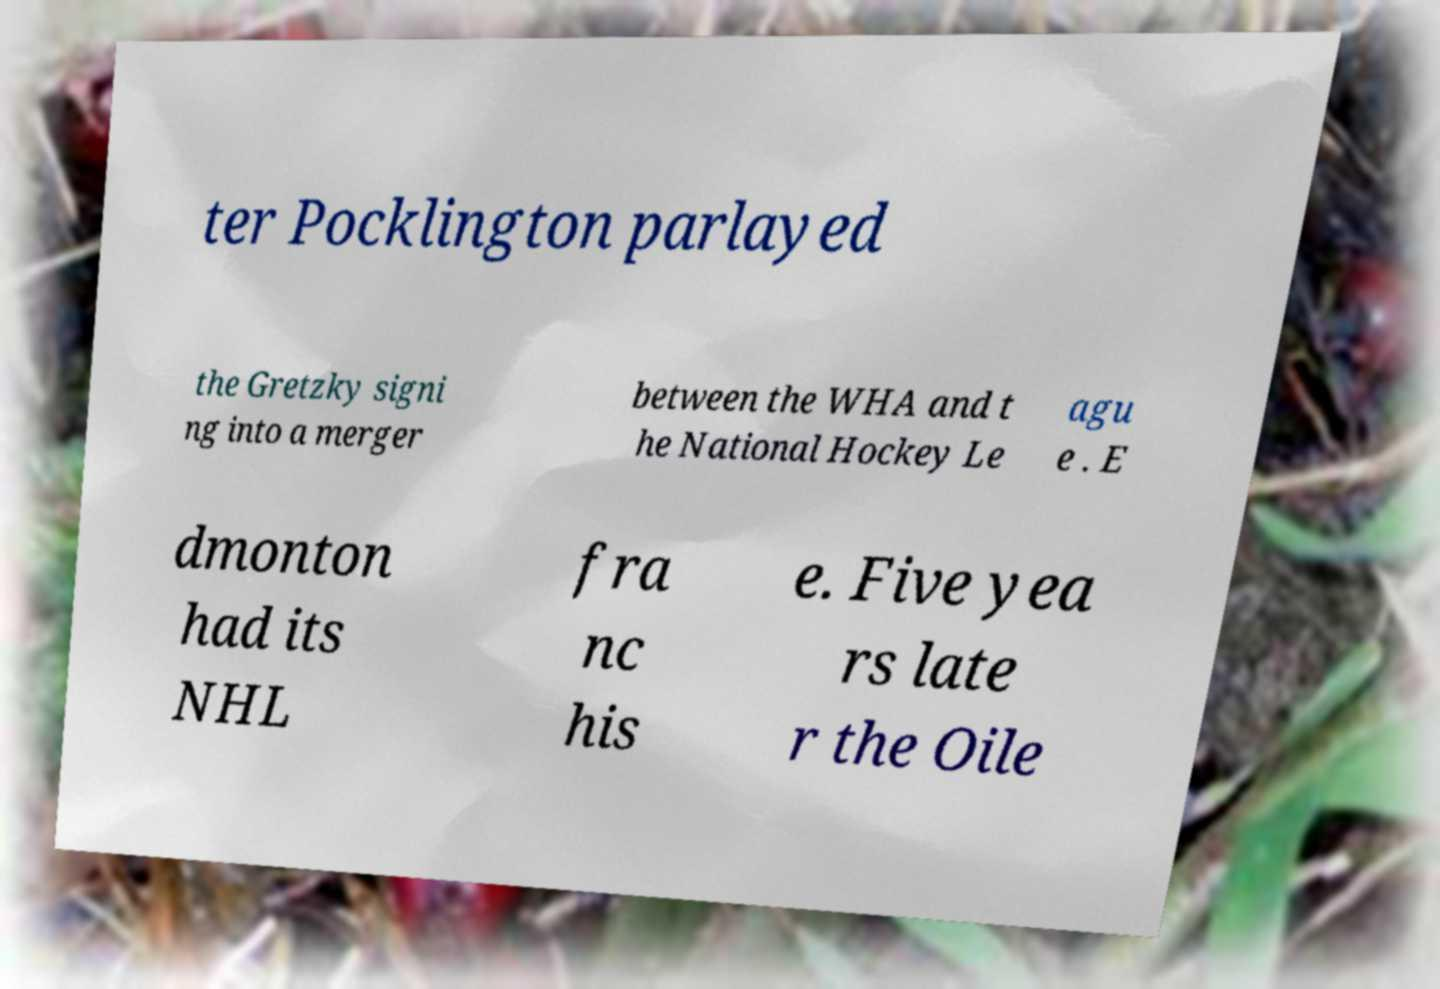For documentation purposes, I need the text within this image transcribed. Could you provide that? ter Pocklington parlayed the Gretzky signi ng into a merger between the WHA and t he National Hockey Le agu e . E dmonton had its NHL fra nc his e. Five yea rs late r the Oile 